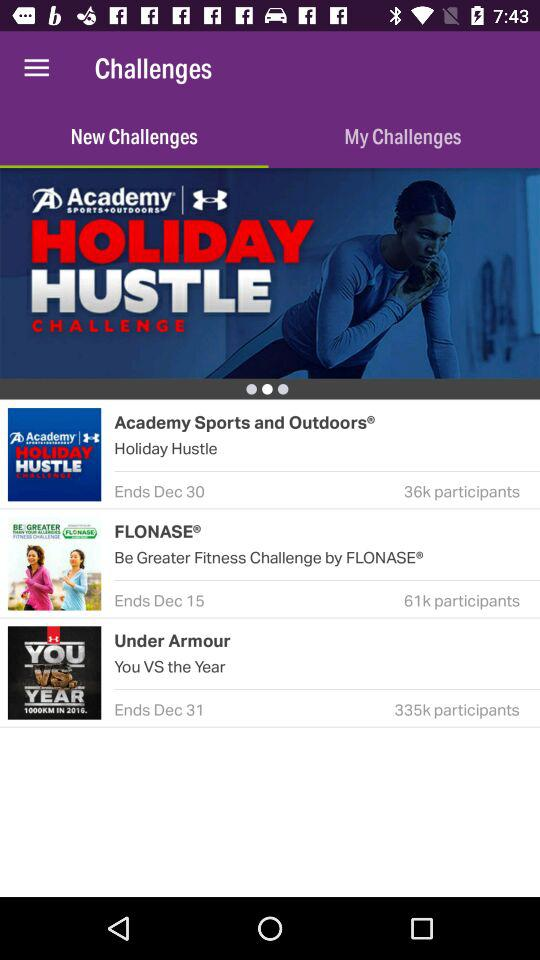How many participants are there "Under Armour"? There are 335,000 participants. 